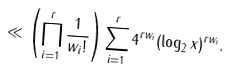<formula> <loc_0><loc_0><loc_500><loc_500>\ll \left ( \prod _ { i = 1 } ^ { r } \frac { 1 } { w _ { i } ! } \right ) \sum _ { i = 1 } ^ { r } 4 ^ { r w _ { i } } ( \log _ { 2 } x ) ^ { r w _ { i } } .</formula> 